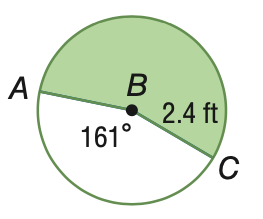Answer the mathemtical geometry problem and directly provide the correct option letter.
Question: Find the area of the shaded sector. Round to the nearest tenth.
Choices: A: 6.7 B: 8.1 C: 8.3 D: 10.0 D 